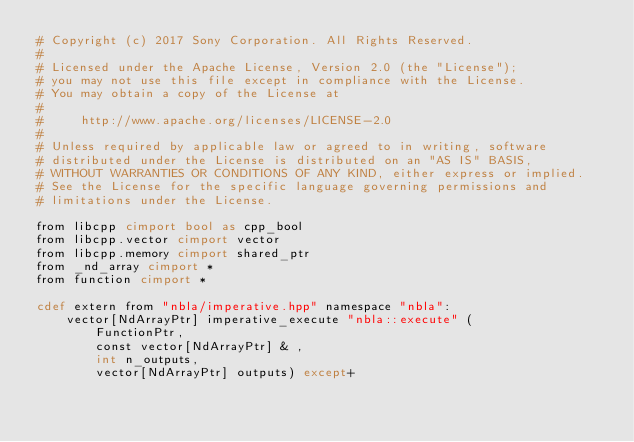<code> <loc_0><loc_0><loc_500><loc_500><_Cython_># Copyright (c) 2017 Sony Corporation. All Rights Reserved.
#
# Licensed under the Apache License, Version 2.0 (the "License");
# you may not use this file except in compliance with the License.
# You may obtain a copy of the License at
#
#     http://www.apache.org/licenses/LICENSE-2.0
#
# Unless required by applicable law or agreed to in writing, software
# distributed under the License is distributed on an "AS IS" BASIS,
# WITHOUT WARRANTIES OR CONDITIONS OF ANY KIND, either express or implied.
# See the License for the specific language governing permissions and
# limitations under the License.

from libcpp cimport bool as cpp_bool
from libcpp.vector cimport vector
from libcpp.memory cimport shared_ptr
from _nd_array cimport *
from function cimport *

cdef extern from "nbla/imperative.hpp" namespace "nbla":
    vector[NdArrayPtr] imperative_execute "nbla::execute" (
        FunctionPtr,
        const vector[NdArrayPtr] & ,
        int n_outputs,
        vector[NdArrayPtr] outputs) except+
</code> 